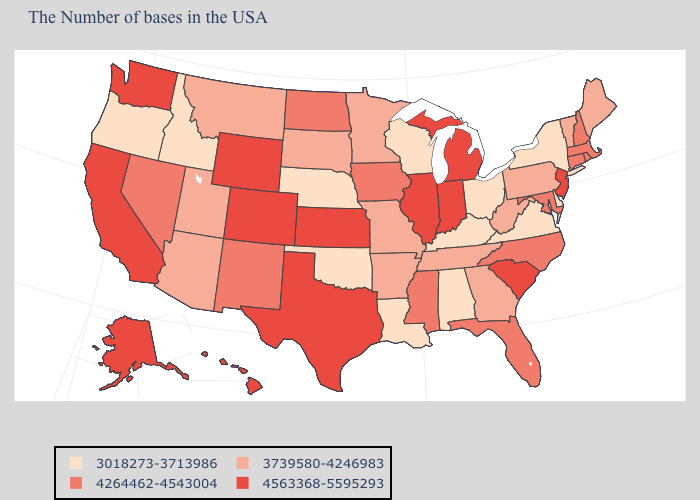Name the states that have a value in the range 3739580-4246983?
Give a very brief answer. Maine, Vermont, Pennsylvania, West Virginia, Georgia, Tennessee, Missouri, Arkansas, Minnesota, South Dakota, Utah, Montana, Arizona. Name the states that have a value in the range 3018273-3713986?
Write a very short answer. New York, Delaware, Virginia, Ohio, Kentucky, Alabama, Wisconsin, Louisiana, Nebraska, Oklahoma, Idaho, Oregon. What is the value of Nevada?
Be succinct. 4264462-4543004. What is the value of Kentucky?
Quick response, please. 3018273-3713986. Does Alabama have the lowest value in the South?
Short answer required. Yes. Name the states that have a value in the range 3739580-4246983?
Short answer required. Maine, Vermont, Pennsylvania, West Virginia, Georgia, Tennessee, Missouri, Arkansas, Minnesota, South Dakota, Utah, Montana, Arizona. Among the states that border Nevada , which have the lowest value?
Give a very brief answer. Idaho, Oregon. Does New Jersey have the highest value in the Northeast?
Concise answer only. Yes. How many symbols are there in the legend?
Quick response, please. 4. What is the lowest value in states that border Georgia?
Write a very short answer. 3018273-3713986. What is the value of New York?
Be succinct. 3018273-3713986. What is the value of Nevada?
Answer briefly. 4264462-4543004. Among the states that border Alabama , does Florida have the highest value?
Quick response, please. Yes. Which states have the lowest value in the USA?
Give a very brief answer. New York, Delaware, Virginia, Ohio, Kentucky, Alabama, Wisconsin, Louisiana, Nebraska, Oklahoma, Idaho, Oregon. What is the lowest value in states that border Tennessee?
Concise answer only. 3018273-3713986. 